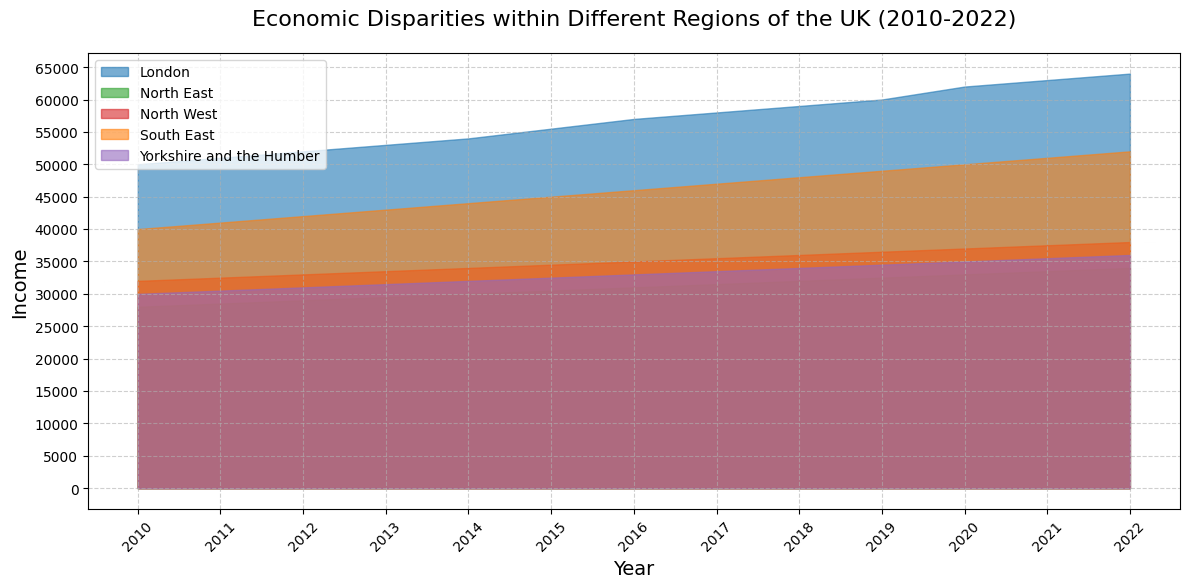What is the average income in the North East across the decade? Sum the yearly incomes for North East from 2010 to 2022: (28000 + 28500 + 29000 + 29500 + 30000 + 30500 + 31000 + 31500 + 32000 + 32500 + 33000 + 33500 + 34000) = 410500. Divide by the number of years (13) to get the average: 410500 / 13 = 31500
Answer: 31500 Which region had the highest income throughout the entire decade? Compare the heights of the area for each region throughout the figure. London consistently has the tallest area graph, indicating the highest income.
Answer: London How much did the income of the South East increase from 2010 to 2022? Subtract the income in 2010 (40000) from the income in 2022 (52000): 52000 - 40000 = 12000
Answer: 12000 Did Yorkshire and the Humber ever surpass North West in terms of income during the decade? Compare the heights of the areas representing Yorkshire and the Humber and North West. North West remains consistently higher throughout the period.
Answer: No What is the difference between the highest and lowest income values in 2022? Identify the highest (London: 64000) and lowest (North East: 34000) income values for 2022. Subtract the lowest from the highest: 64000 - 34000 = 30000
Answer: 30000 Which two regions had the smallest income gap in 2015? Compare the difference in heights of the areas for 2015. The smallest gap is between Yorkshire and the Humber (32500) and North East (30500): 32500 - 30500 = 2000
Answer: Yorkshire and the Humber and North East By how much did the income in London increase from 2010 to 2022? Subtract the income in 2010 (50000) from that in 2022 (64000): 64000 - 50000 = 14000
Answer: 14000 Between London and South East, which region saw a greater income increase from 2016 to 2020? Subtract the income in 2016 from 2020 for both regions: London (62000 - 57000 = 5000), South East (50000 - 46000 = 4000). London saw a greater increase.
Answer: London Were there any years when the income in North West exceeded 36000? Look at the height of the area for North West across the years. In 2022, North West's income is 38000, which exceeds 36000.
Answer: Yes What was the income trend in London over the decade? Observe the height of London's area graph which consistently increases from 50000 in 2010 to 64000 in 2022.
Answer: Increasing 